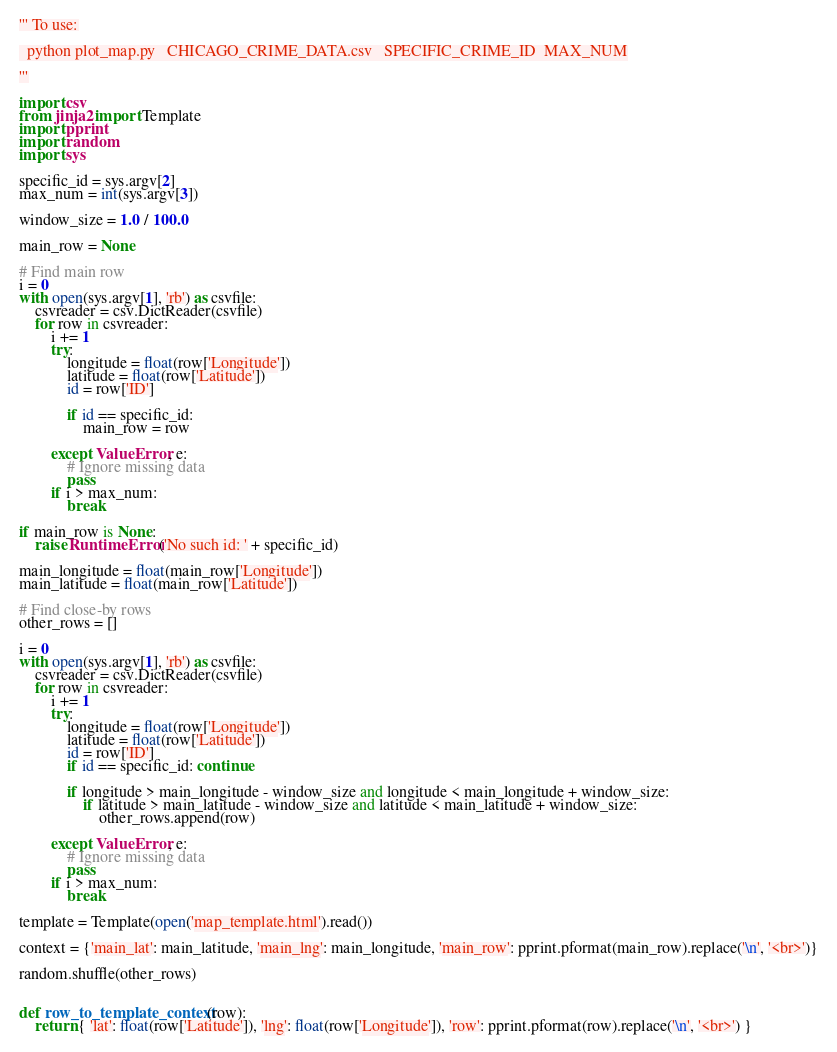Convert code to text. <code><loc_0><loc_0><loc_500><loc_500><_Python_>''' To use:

  python plot_map.py   CHICAGO_CRIME_DATA.csv   SPECIFIC_CRIME_ID  MAX_NUM

'''

import csv
from jinja2 import Template
import pprint
import random
import sys

specific_id = sys.argv[2]
max_num = int(sys.argv[3])

window_size = 1.0 / 100.0

main_row = None

# Find main row
i = 0
with open(sys.argv[1], 'rb') as csvfile:
    csvreader = csv.DictReader(csvfile)
    for row in csvreader:
        i += 1
        try:
            longitude = float(row['Longitude'])
            latitude = float(row['Latitude'])
            id = row['ID']

            if id == specific_id:
                main_row = row

        except ValueError, e:
            # Ignore missing data
            pass
        if i > max_num:
            break

if main_row is None:
    raise RuntimeError('No such id: ' + specific_id)

main_longitude = float(main_row['Longitude'])
main_latitude = float(main_row['Latitude'])

# Find close-by rows
other_rows = []

i = 0
with open(sys.argv[1], 'rb') as csvfile:
    csvreader = csv.DictReader(csvfile)
    for row in csvreader:
        i += 1
        try:
            longitude = float(row['Longitude'])
            latitude = float(row['Latitude'])
            id = row['ID']
            if id == specific_id: continue

            if longitude > main_longitude - window_size and longitude < main_longitude + window_size:
                if latitude > main_latitude - window_size and latitude < main_latitude + window_size:
                    other_rows.append(row)

        except ValueError, e:
            # Ignore missing data
            pass
        if i > max_num:
            break

template = Template(open('map_template.html').read())

context = {'main_lat': main_latitude, 'main_lng': main_longitude, 'main_row': pprint.pformat(main_row).replace('\n', '<br>')}

random.shuffle(other_rows)


def row_to_template_context(row):
    return { 'lat': float(row['Latitude']), 'lng': float(row['Longitude']), 'row': pprint.pformat(row).replace('\n', '<br>') }
</code> 